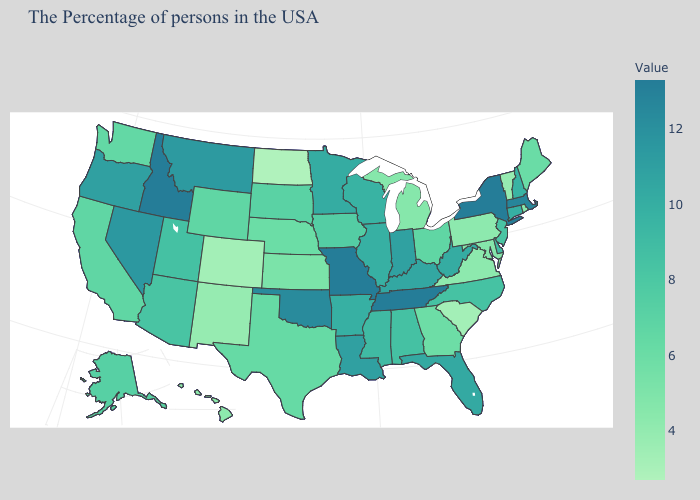Is the legend a continuous bar?
Keep it brief. Yes. Which states have the lowest value in the MidWest?
Answer briefly. North Dakota. Which states have the lowest value in the USA?
Quick response, please. North Dakota. Among the states that border Indiana , does Illinois have the highest value?
Keep it brief. No. Does the map have missing data?
Short answer required. No. 